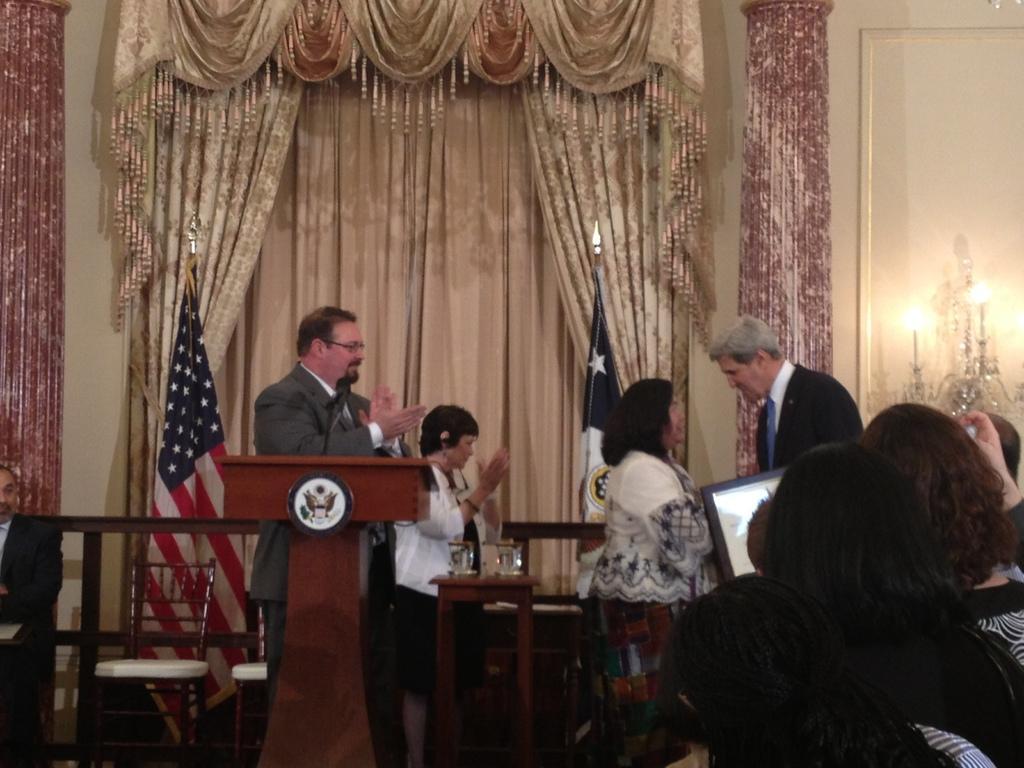Please provide a concise description of this image. These persons are standing. On the background we can see wall,frame,lights,flag,curtain. We can see chairs,table,podium and microphone. On the table we can see glass. 